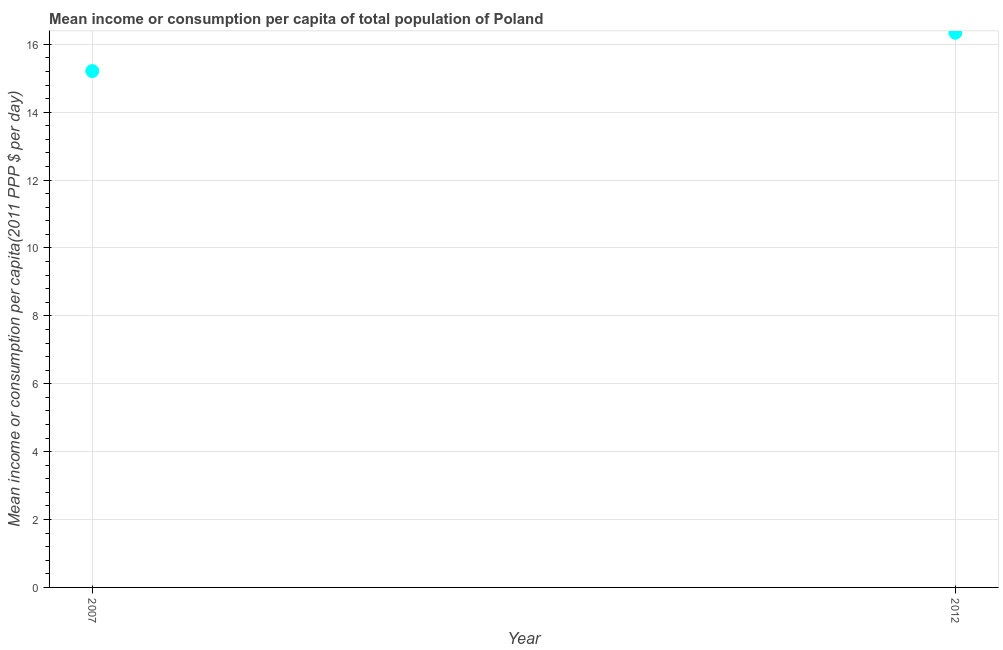What is the mean income or consumption in 2007?
Provide a short and direct response. 15.21. Across all years, what is the maximum mean income or consumption?
Give a very brief answer. 16.34. Across all years, what is the minimum mean income or consumption?
Ensure brevity in your answer.  15.21. In which year was the mean income or consumption minimum?
Your answer should be compact. 2007. What is the sum of the mean income or consumption?
Give a very brief answer. 31.55. What is the difference between the mean income or consumption in 2007 and 2012?
Ensure brevity in your answer.  -1.13. What is the average mean income or consumption per year?
Your answer should be compact. 15.78. What is the median mean income or consumption?
Provide a short and direct response. 15.78. Do a majority of the years between 2007 and 2012 (inclusive) have mean income or consumption greater than 13.2 $?
Give a very brief answer. Yes. What is the ratio of the mean income or consumption in 2007 to that in 2012?
Provide a short and direct response. 0.93. Is the mean income or consumption in 2007 less than that in 2012?
Provide a short and direct response. Yes. Does the mean income or consumption monotonically increase over the years?
Offer a very short reply. Yes. How many dotlines are there?
Keep it short and to the point. 1. Does the graph contain grids?
Ensure brevity in your answer.  Yes. What is the title of the graph?
Your answer should be compact. Mean income or consumption per capita of total population of Poland. What is the label or title of the X-axis?
Offer a terse response. Year. What is the label or title of the Y-axis?
Provide a succinct answer. Mean income or consumption per capita(2011 PPP $ per day). What is the Mean income or consumption per capita(2011 PPP $ per day) in 2007?
Make the answer very short. 15.21. What is the Mean income or consumption per capita(2011 PPP $ per day) in 2012?
Provide a short and direct response. 16.34. What is the difference between the Mean income or consumption per capita(2011 PPP $ per day) in 2007 and 2012?
Provide a short and direct response. -1.13. What is the ratio of the Mean income or consumption per capita(2011 PPP $ per day) in 2007 to that in 2012?
Your response must be concise. 0.93. 